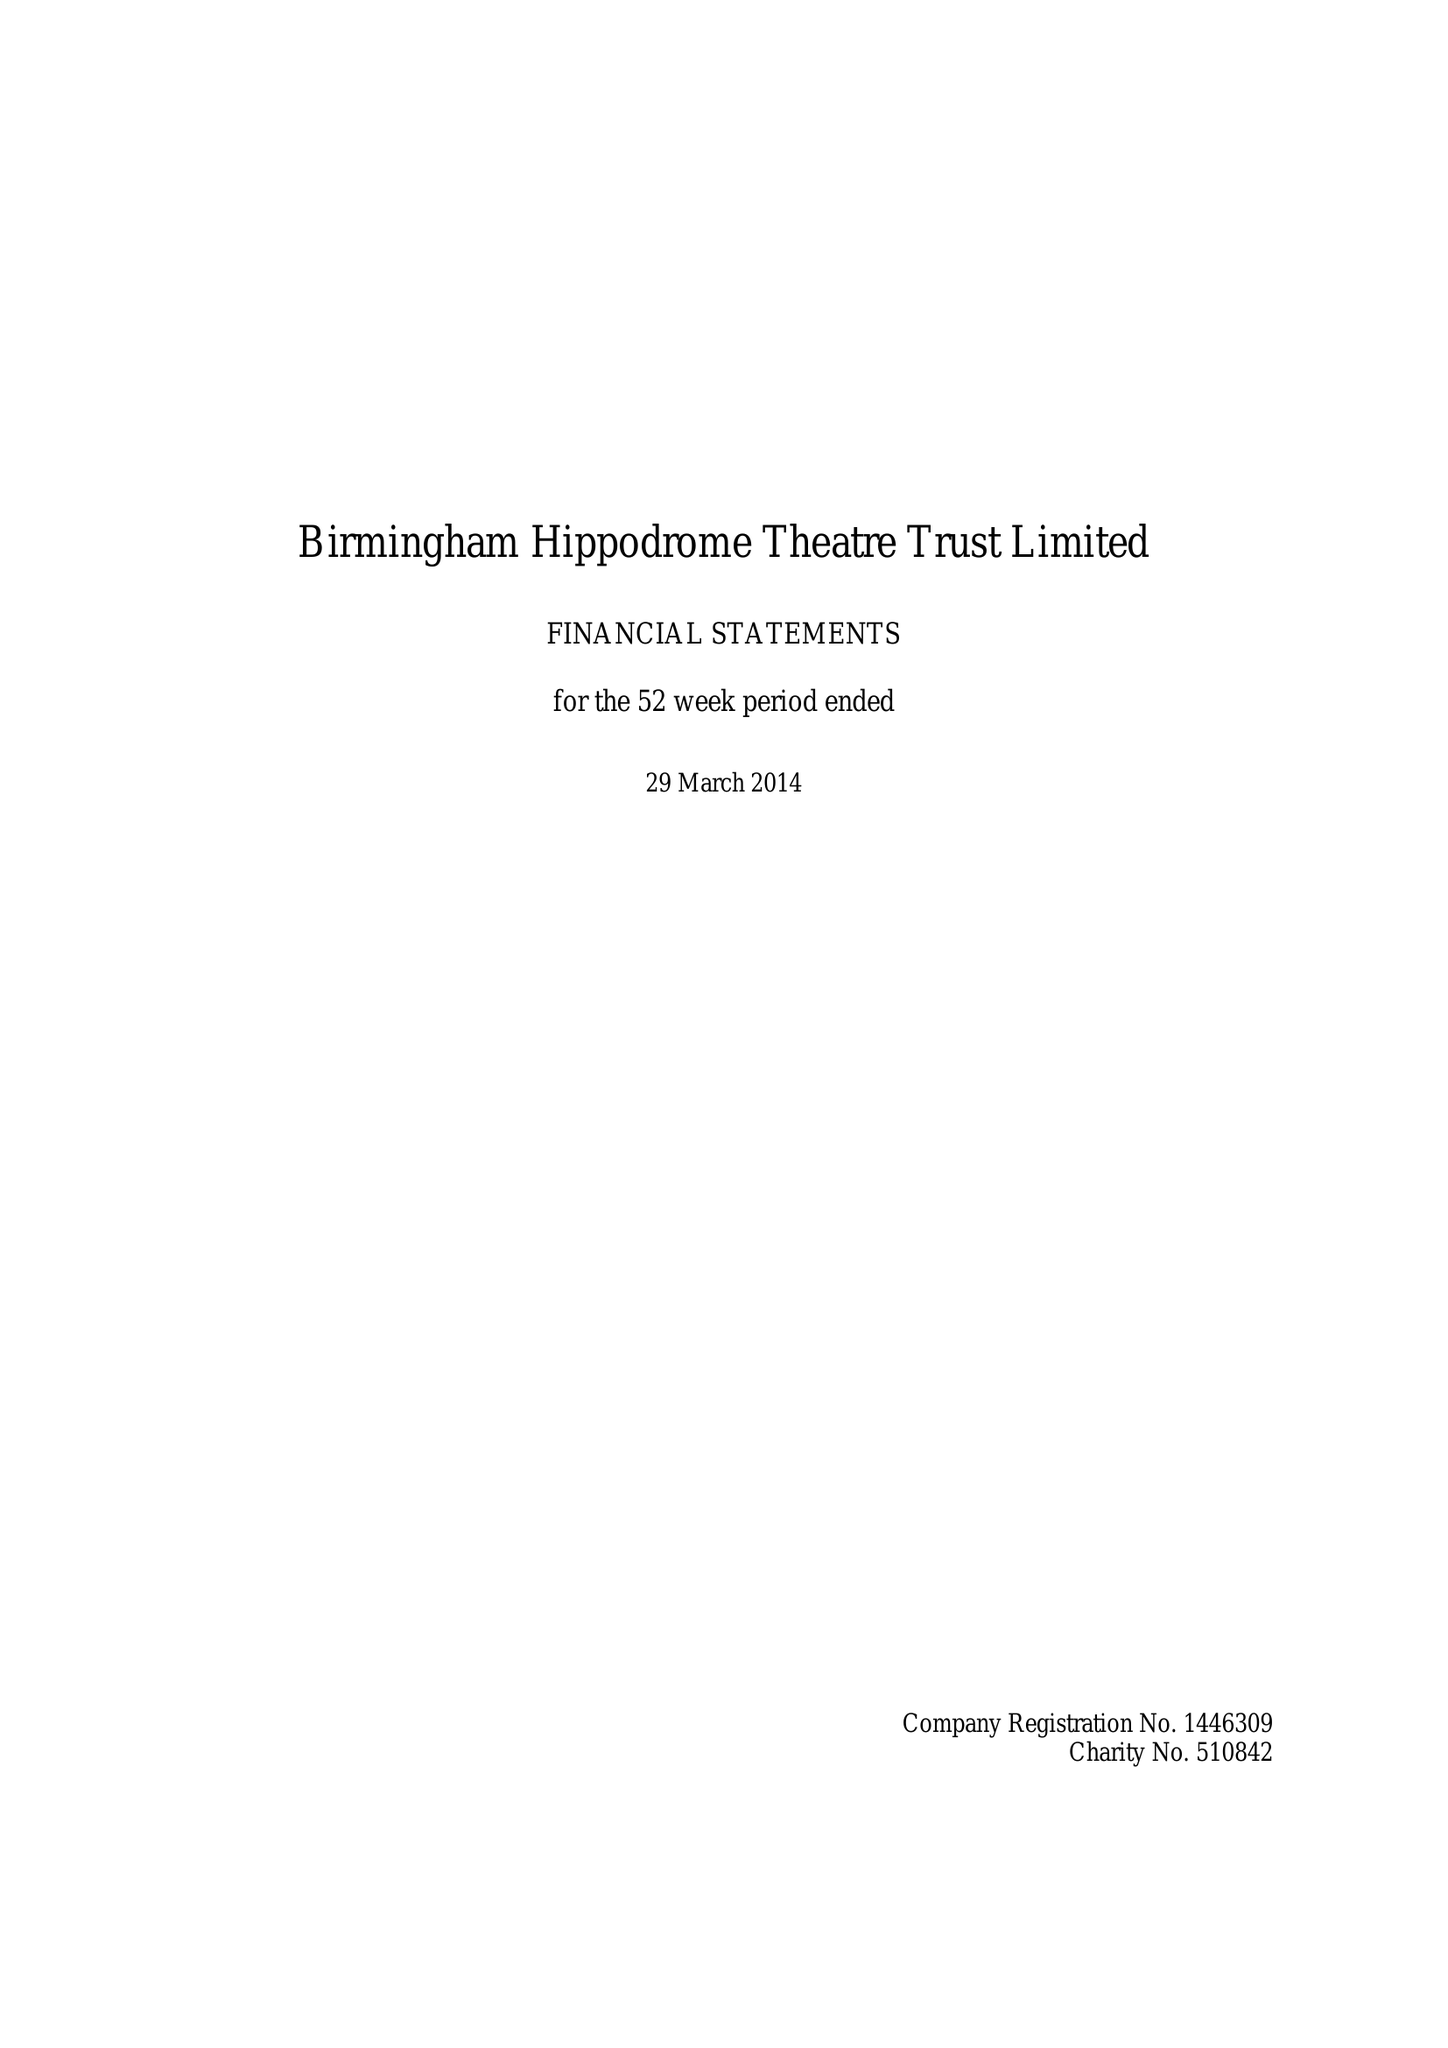What is the value for the charity_name?
Answer the question using a single word or phrase. Birmingham Hippodrome Theatre Trust Ltd. 